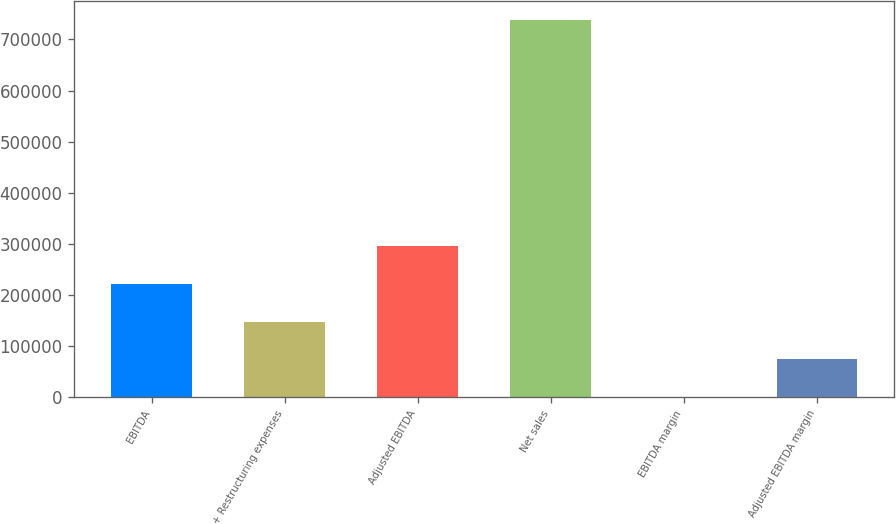Convert chart. <chart><loc_0><loc_0><loc_500><loc_500><bar_chart><fcel>EBITDA<fcel>+ Restructuring expenses<fcel>Adjusted EBITDA<fcel>Net sales<fcel>EBITDA margin<fcel>Adjusted EBITDA margin<nl><fcel>221718<fcel>147821<fcel>295615<fcel>738996<fcel>27.2<fcel>73924.1<nl></chart> 